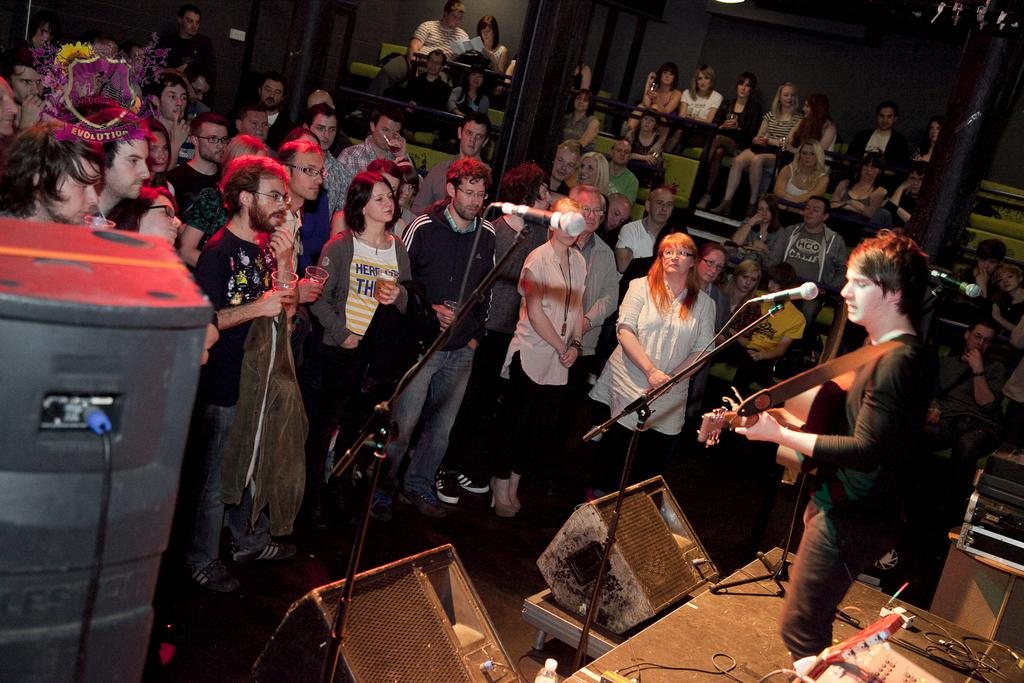What is the person on the stage doing? The person on the stage is playing guitar. What equipment is in front of the person? There is a microphone and speakers in front of the person. Who is present in front of the stage? There are people standing in front of the stage. What is the seating arrangement for the people in the background? There are people seated in chairs in the background. What type of pets can be seen playing with the skateboard in the image? There are no pets or skateboards present in the image. 